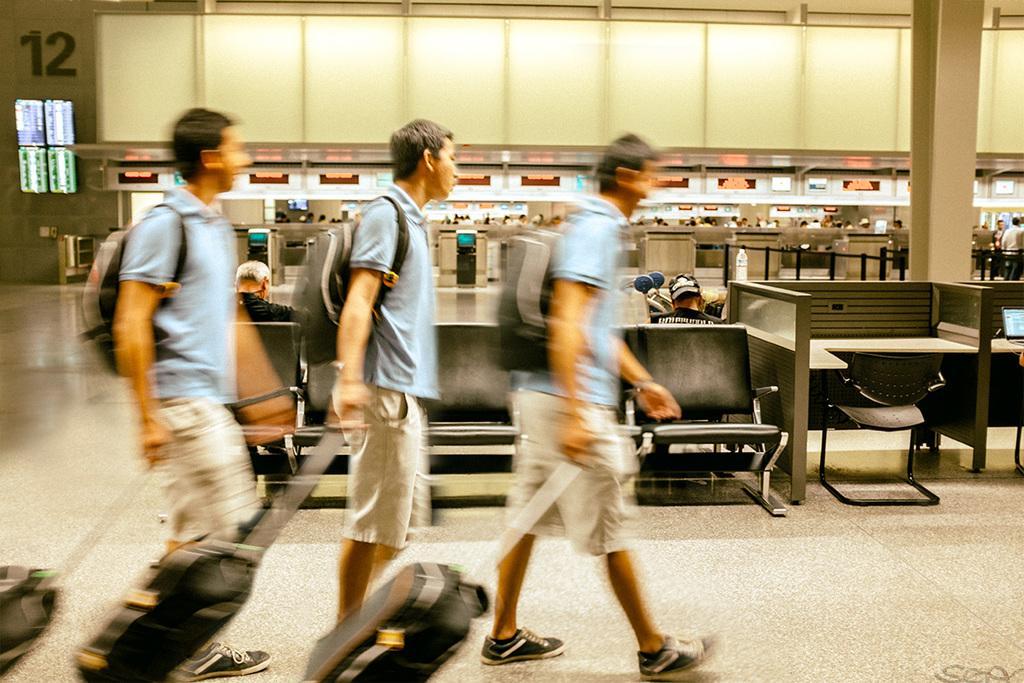How would you summarize this image in a sentence or two? This is an edited image where there is a person holding a trolley bag and walking , and at the background there are two persons sitting on the chairs, laptop, bottle, screens attached to the wall, lights, baggage counters , group of people standing. 